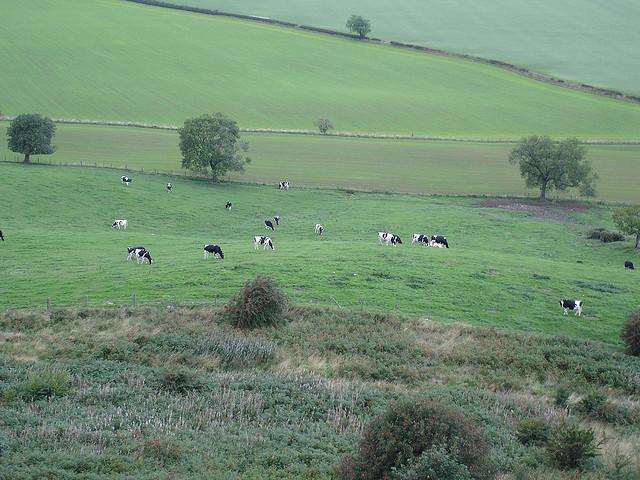What game would you play when you saw this as a child?
Concise answer only. Cow tipping. Is this a cow farm?
Keep it brief. Yes. Are any brown cows in this picture?
Give a very brief answer. No. 